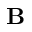Convert formula to latex. <formula><loc_0><loc_0><loc_500><loc_500>B</formula> 